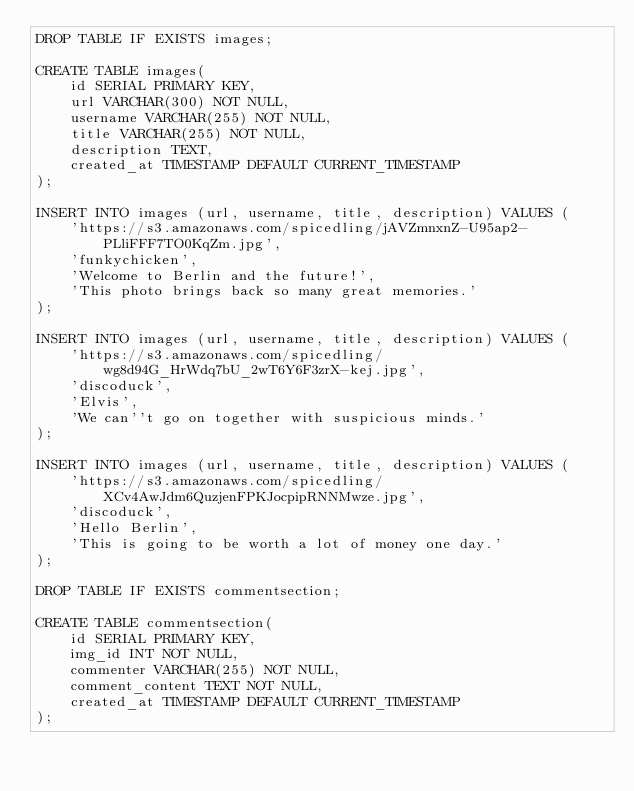Convert code to text. <code><loc_0><loc_0><loc_500><loc_500><_SQL_>DROP TABLE IF EXISTS images;

CREATE TABLE images(
    id SERIAL PRIMARY KEY,
    url VARCHAR(300) NOT NULL,
    username VARCHAR(255) NOT NULL,
    title VARCHAR(255) NOT NULL,
    description TEXT,
    created_at TIMESTAMP DEFAULT CURRENT_TIMESTAMP
);

INSERT INTO images (url, username, title, description) VALUES (
    'https://s3.amazonaws.com/spicedling/jAVZmnxnZ-U95ap2-PLliFFF7TO0KqZm.jpg',
    'funkychicken',
    'Welcome to Berlin and the future!',
    'This photo brings back so many great memories.'
);

INSERT INTO images (url, username, title, description) VALUES (
    'https://s3.amazonaws.com/spicedling/wg8d94G_HrWdq7bU_2wT6Y6F3zrX-kej.jpg',
    'discoduck',
    'Elvis',
    'We can''t go on together with suspicious minds.'
);

INSERT INTO images (url, username, title, description) VALUES (
    'https://s3.amazonaws.com/spicedling/XCv4AwJdm6QuzjenFPKJocpipRNNMwze.jpg',
    'discoduck',
    'Hello Berlin',
    'This is going to be worth a lot of money one day.'
);

DROP TABLE IF EXISTS commentsection;

CREATE TABLE commentsection(
    id SERIAL PRIMARY KEY,
    img_id INT NOT NULL,
    commenter VARCHAR(255) NOT NULL,
    comment_content TEXT NOT NULL,
    created_at TIMESTAMP DEFAULT CURRENT_TIMESTAMP
);
</code> 